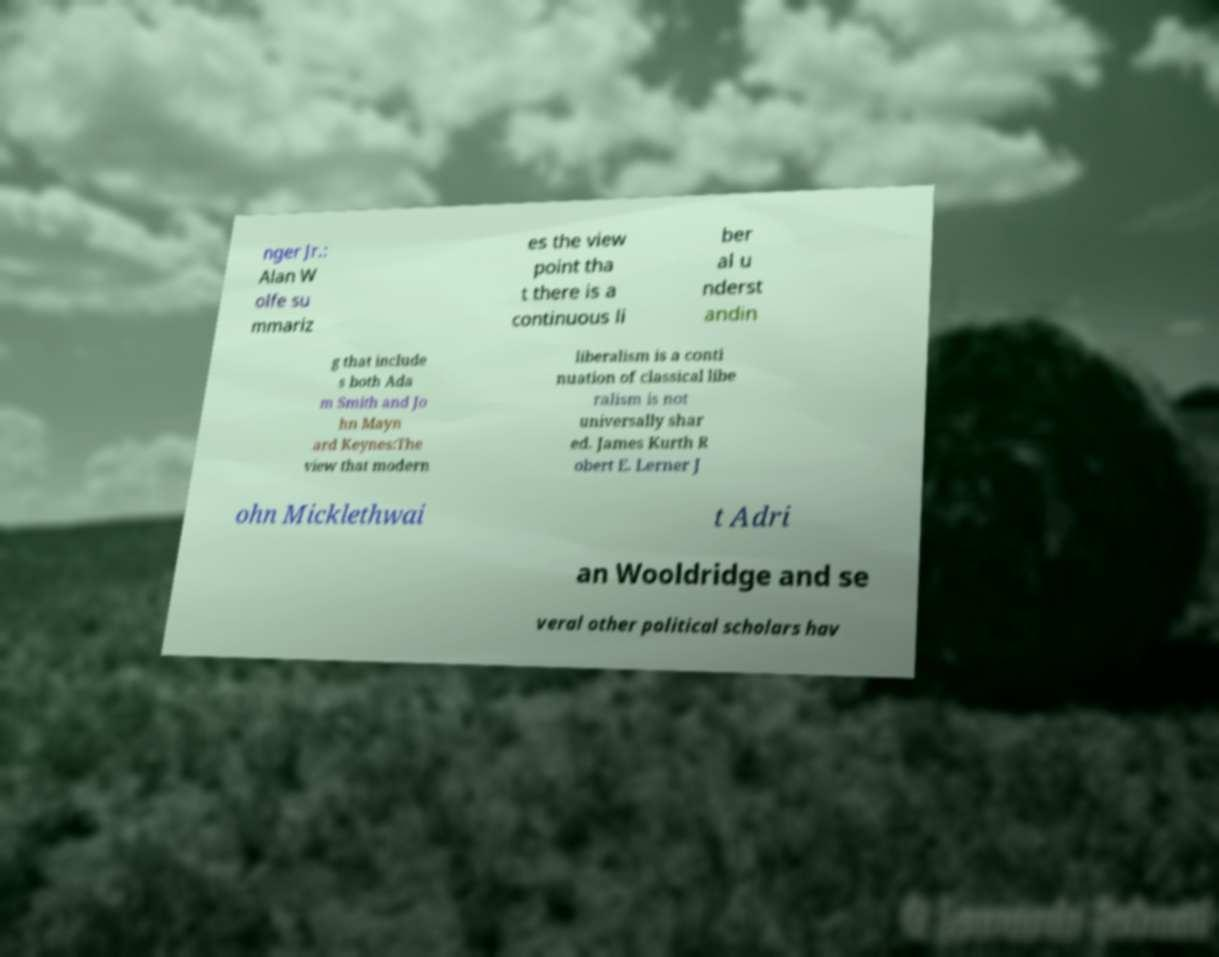For documentation purposes, I need the text within this image transcribed. Could you provide that? nger Jr.: Alan W olfe su mmariz es the view point tha t there is a continuous li ber al u nderst andin g that include s both Ada m Smith and Jo hn Mayn ard Keynes:The view that modern liberalism is a conti nuation of classical libe ralism is not universally shar ed. James Kurth R obert E. Lerner J ohn Micklethwai t Adri an Wooldridge and se veral other political scholars hav 